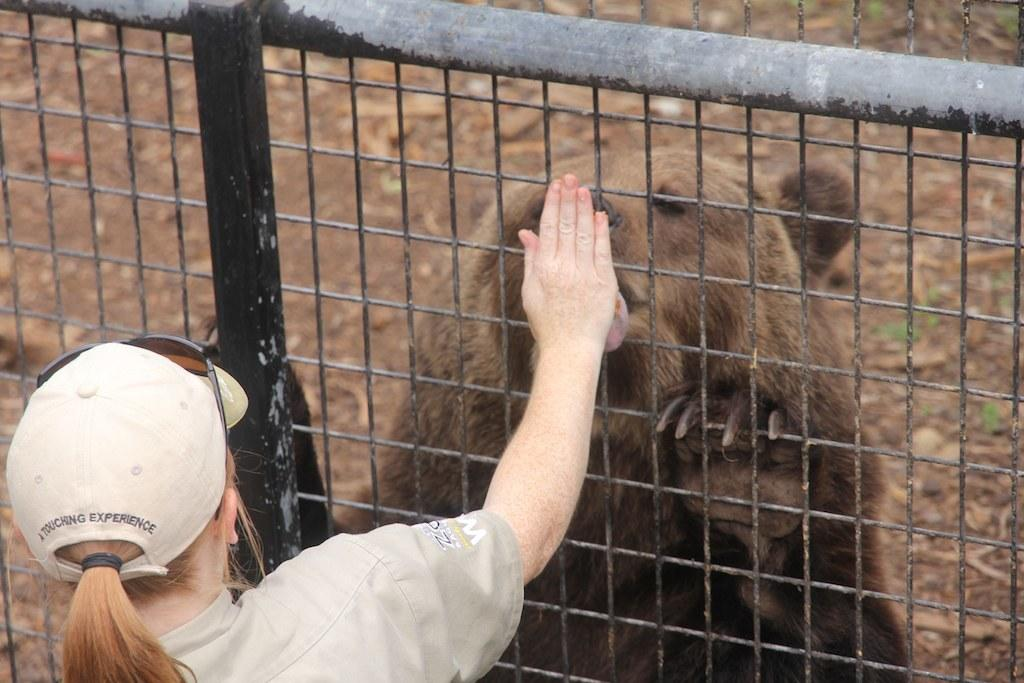Who is present in the image? There is a woman in the image. What is the woman wearing on her head? The woman is wearing a hat. What accessory is the woman wearing on her face? The woman is wearing glasses. What type of barrier is visible in the image? There is a fencing in the image. What animal can be seen behind the fencing? There is a bear behind the fencing. What chess piece does the woman's brother receive as a reward in the image? There is no chess piece, brother, or reward present in the image. 